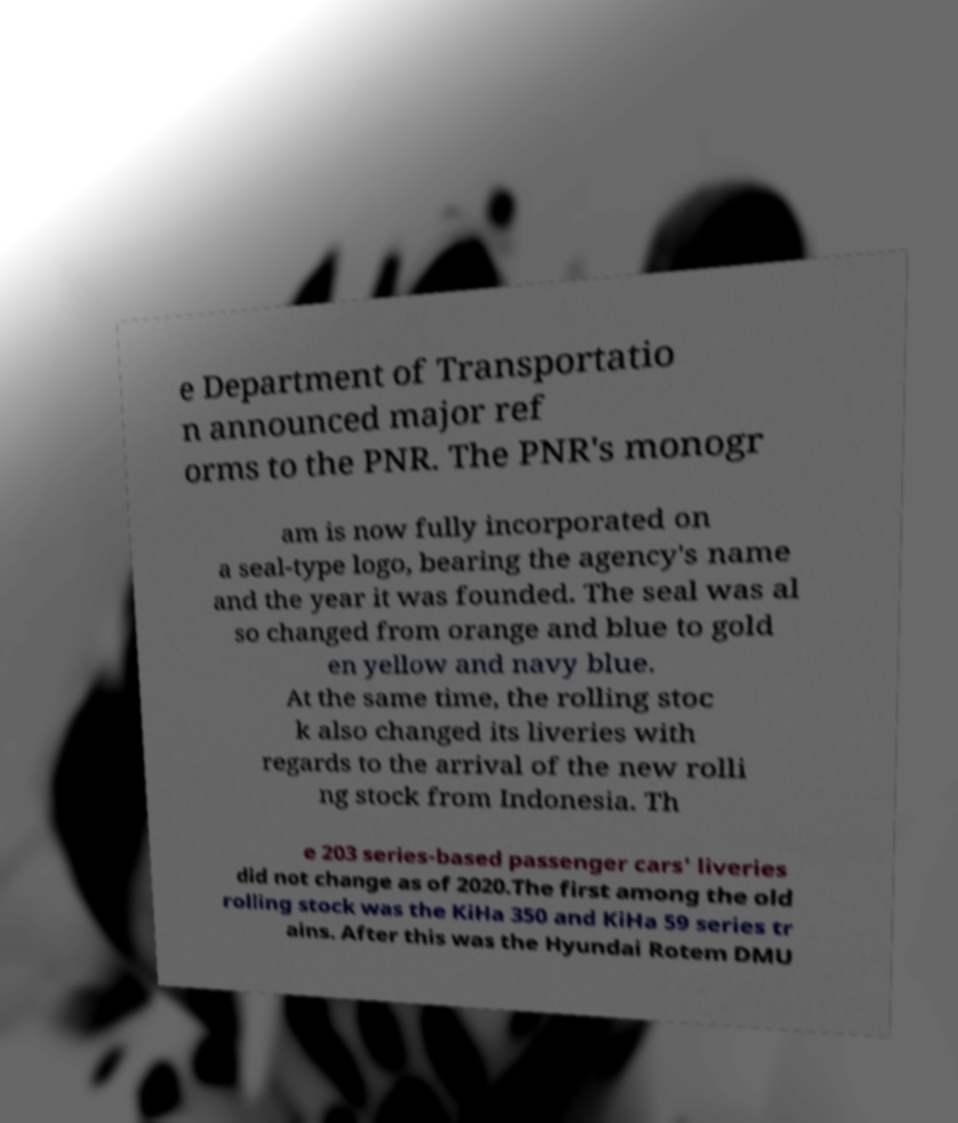Please identify and transcribe the text found in this image. e Department of Transportatio n announced major ref orms to the PNR. The PNR's monogr am is now fully incorporated on a seal-type logo, bearing the agency's name and the year it was founded. The seal was al so changed from orange and blue to gold en yellow and navy blue. At the same time, the rolling stoc k also changed its liveries with regards to the arrival of the new rolli ng stock from Indonesia. Th e 203 series-based passenger cars' liveries did not change as of 2020.The first among the old rolling stock was the KiHa 350 and KiHa 59 series tr ains. After this was the Hyundai Rotem DMU 